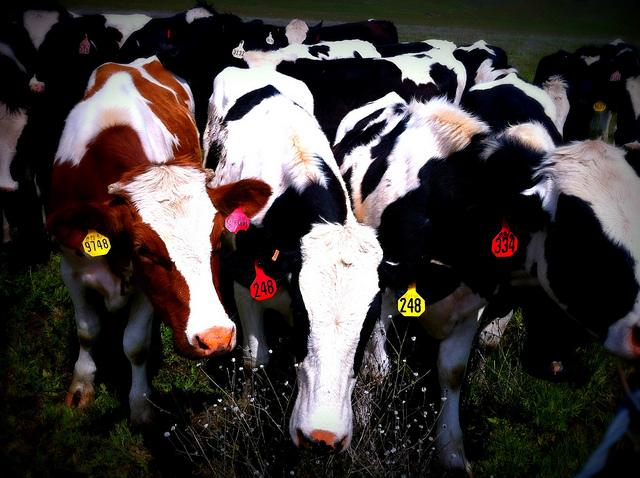What is the largest number on the yellow tags? Please explain your reasoning. 9748. There are two yellow tags, one is 248 the other is 9748. thousand is a higher number than hundred. 